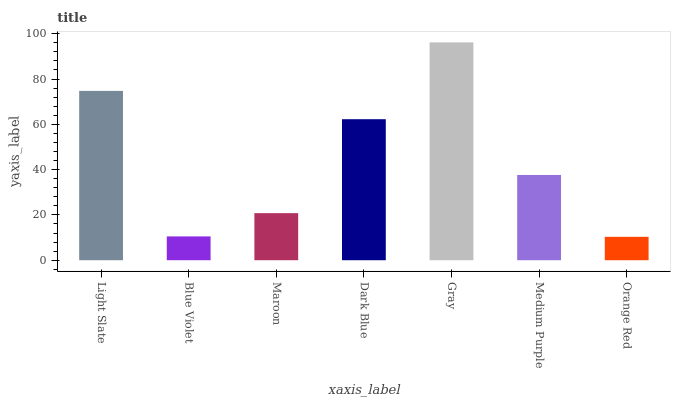Is Orange Red the minimum?
Answer yes or no. Yes. Is Gray the maximum?
Answer yes or no. Yes. Is Blue Violet the minimum?
Answer yes or no. No. Is Blue Violet the maximum?
Answer yes or no. No. Is Light Slate greater than Blue Violet?
Answer yes or no. Yes. Is Blue Violet less than Light Slate?
Answer yes or no. Yes. Is Blue Violet greater than Light Slate?
Answer yes or no. No. Is Light Slate less than Blue Violet?
Answer yes or no. No. Is Medium Purple the high median?
Answer yes or no. Yes. Is Medium Purple the low median?
Answer yes or no. Yes. Is Light Slate the high median?
Answer yes or no. No. Is Light Slate the low median?
Answer yes or no. No. 